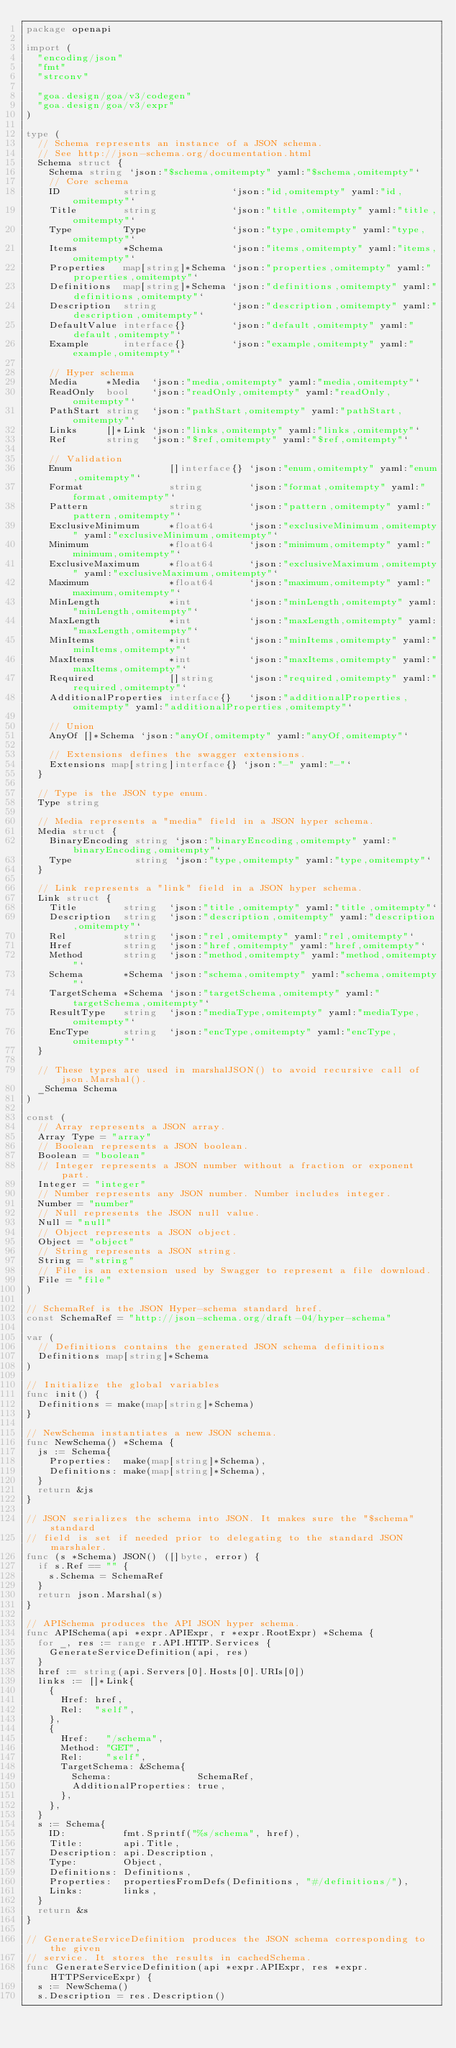Convert code to text. <code><loc_0><loc_0><loc_500><loc_500><_Go_>package openapi

import (
	"encoding/json"
	"fmt"
	"strconv"

	"goa.design/goa/v3/codegen"
	"goa.design/goa/v3/expr"
)

type (
	// Schema represents an instance of a JSON schema.
	// See http://json-schema.org/documentation.html
	Schema struct {
		Schema string `json:"$schema,omitempty" yaml:"$schema,omitempty"`
		// Core schema
		ID           string             `json:"id,omitempty" yaml:"id,omitempty"`
		Title        string             `json:"title,omitempty" yaml:"title,omitempty"`
		Type         Type               `json:"type,omitempty" yaml:"type,omitempty"`
		Items        *Schema            `json:"items,omitempty" yaml:"items,omitempty"`
		Properties   map[string]*Schema `json:"properties,omitempty" yaml:"properties,omitempty"`
		Definitions  map[string]*Schema `json:"definitions,omitempty" yaml:"definitions,omitempty"`
		Description  string             `json:"description,omitempty" yaml:"description,omitempty"`
		DefaultValue interface{}        `json:"default,omitempty" yaml:"default,omitempty"`
		Example      interface{}        `json:"example,omitempty" yaml:"example,omitempty"`

		// Hyper schema
		Media     *Media  `json:"media,omitempty" yaml:"media,omitempty"`
		ReadOnly  bool    `json:"readOnly,omitempty" yaml:"readOnly,omitempty"`
		PathStart string  `json:"pathStart,omitempty" yaml:"pathStart,omitempty"`
		Links     []*Link `json:"links,omitempty" yaml:"links,omitempty"`
		Ref       string  `json:"$ref,omitempty" yaml:"$ref,omitempty"`

		// Validation
		Enum                 []interface{} `json:"enum,omitempty" yaml:"enum,omitempty"`
		Format               string        `json:"format,omitempty" yaml:"format,omitempty"`
		Pattern              string        `json:"pattern,omitempty" yaml:"pattern,omitempty"`
		ExclusiveMinimum     *float64      `json:"exclusiveMinimum,omitempty" yaml:"exclusiveMinimum,omitempty"`
		Minimum              *float64      `json:"minimum,omitempty" yaml:"minimum,omitempty"`
		ExclusiveMaximum     *float64      `json:"exclusiveMaximum,omitempty" yaml:"exclusiveMaximum,omitempty"`
		Maximum              *float64      `json:"maximum,omitempty" yaml:"maximum,omitempty"`
		MinLength            *int          `json:"minLength,omitempty" yaml:"minLength,omitempty"`
		MaxLength            *int          `json:"maxLength,omitempty" yaml:"maxLength,omitempty"`
		MinItems             *int          `json:"minItems,omitempty" yaml:"minItems,omitempty"`
		MaxItems             *int          `json:"maxItems,omitempty" yaml:"maxItems,omitempty"`
		Required             []string      `json:"required,omitempty" yaml:"required,omitempty"`
		AdditionalProperties interface{}   `json:"additionalProperties,omitempty" yaml:"additionalProperties,omitempty"`

		// Union
		AnyOf []*Schema `json:"anyOf,omitempty" yaml:"anyOf,omitempty"`

		// Extensions defines the swagger extensions.
		Extensions map[string]interface{} `json:"-" yaml:"-"`
	}

	// Type is the JSON type enum.
	Type string

	// Media represents a "media" field in a JSON hyper schema.
	Media struct {
		BinaryEncoding string `json:"binaryEncoding,omitempty" yaml:"binaryEncoding,omitempty"`
		Type           string `json:"type,omitempty" yaml:"type,omitempty"`
	}

	// Link represents a "link" field in a JSON hyper schema.
	Link struct {
		Title        string  `json:"title,omitempty" yaml:"title,omitempty"`
		Description  string  `json:"description,omitempty" yaml:"description,omitempty"`
		Rel          string  `json:"rel,omitempty" yaml:"rel,omitempty"`
		Href         string  `json:"href,omitempty" yaml:"href,omitempty"`
		Method       string  `json:"method,omitempty" yaml:"method,omitempty"`
		Schema       *Schema `json:"schema,omitempty" yaml:"schema,omitempty"`
		TargetSchema *Schema `json:"targetSchema,omitempty" yaml:"targetSchema,omitempty"`
		ResultType   string  `json:"mediaType,omitempty" yaml:"mediaType,omitempty"`
		EncType      string  `json:"encType,omitempty" yaml:"encType,omitempty"`
	}

	// These types are used in marshalJSON() to avoid recursive call of json.Marshal().
	_Schema Schema
)

const (
	// Array represents a JSON array.
	Array Type = "array"
	// Boolean represents a JSON boolean.
	Boolean = "boolean"
	// Integer represents a JSON number without a fraction or exponent part.
	Integer = "integer"
	// Number represents any JSON number. Number includes integer.
	Number = "number"
	// Null represents the JSON null value.
	Null = "null"
	// Object represents a JSON object.
	Object = "object"
	// String represents a JSON string.
	String = "string"
	// File is an extension used by Swagger to represent a file download.
	File = "file"
)

// SchemaRef is the JSON Hyper-schema standard href.
const SchemaRef = "http://json-schema.org/draft-04/hyper-schema"

var (
	// Definitions contains the generated JSON schema definitions
	Definitions map[string]*Schema
)

// Initialize the global variables
func init() {
	Definitions = make(map[string]*Schema)
}

// NewSchema instantiates a new JSON schema.
func NewSchema() *Schema {
	js := Schema{
		Properties:  make(map[string]*Schema),
		Definitions: make(map[string]*Schema),
	}
	return &js
}

// JSON serializes the schema into JSON. It makes sure the "$schema" standard
// field is set if needed prior to delegating to the standard JSON marshaler.
func (s *Schema) JSON() ([]byte, error) {
	if s.Ref == "" {
		s.Schema = SchemaRef
	}
	return json.Marshal(s)
}

// APISchema produces the API JSON hyper schema.
func APISchema(api *expr.APIExpr, r *expr.RootExpr) *Schema {
	for _, res := range r.API.HTTP.Services {
		GenerateServiceDefinition(api, res)
	}
	href := string(api.Servers[0].Hosts[0].URIs[0])
	links := []*Link{
		{
			Href: href,
			Rel:  "self",
		},
		{
			Href:   "/schema",
			Method: "GET",
			Rel:    "self",
			TargetSchema: &Schema{
				Schema:               SchemaRef,
				AdditionalProperties: true,
			},
		},
	}
	s := Schema{
		ID:          fmt.Sprintf("%s/schema", href),
		Title:       api.Title,
		Description: api.Description,
		Type:        Object,
		Definitions: Definitions,
		Properties:  propertiesFromDefs(Definitions, "#/definitions/"),
		Links:       links,
	}
	return &s
}

// GenerateServiceDefinition produces the JSON schema corresponding to the given
// service. It stores the results in cachedSchema.
func GenerateServiceDefinition(api *expr.APIExpr, res *expr.HTTPServiceExpr) {
	s := NewSchema()
	s.Description = res.Description()</code> 